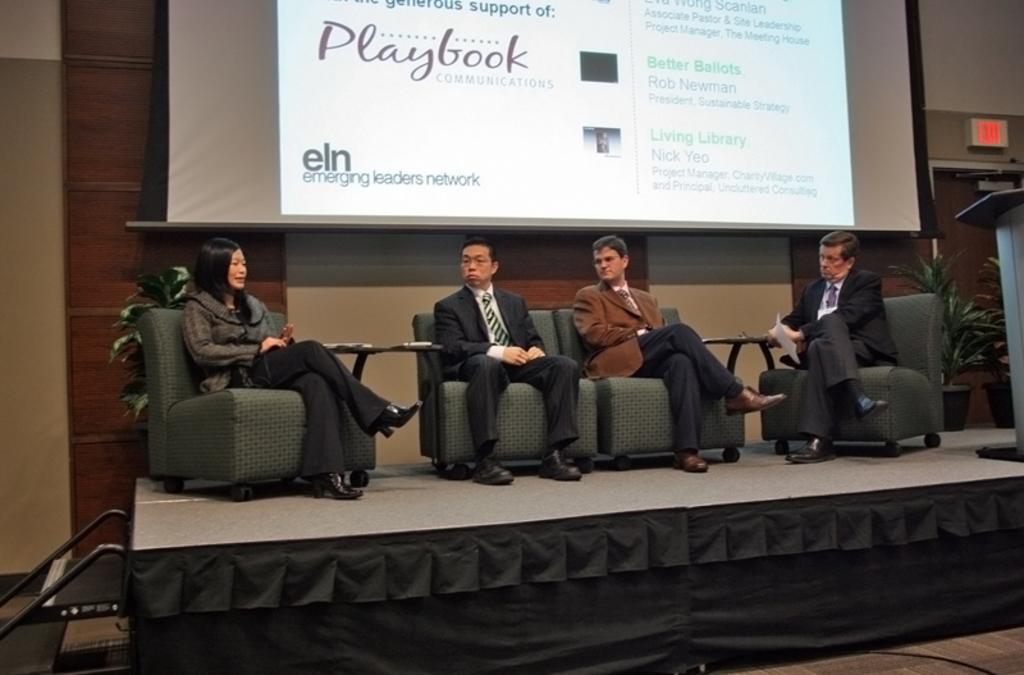Please provide a concise description of this image. This picture shows a group of people seated on the chairs and we see a projector screen on the back and we see a podium 